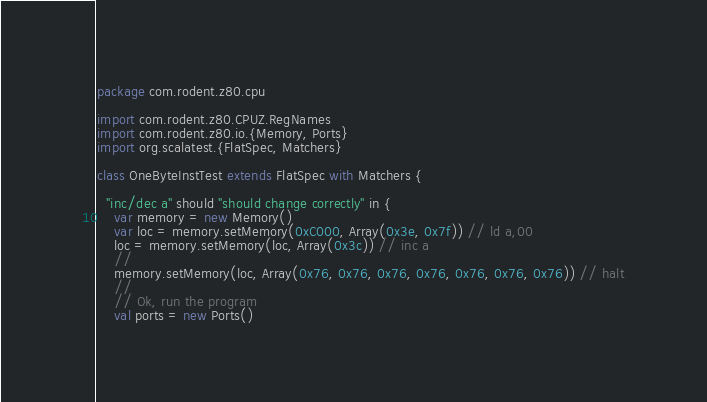Convert code to text. <code><loc_0><loc_0><loc_500><loc_500><_Scala_>package com.rodent.z80.cpu

import com.rodent.z80.CPUZ.RegNames
import com.rodent.z80.io.{Memory, Ports}
import org.scalatest.{FlatSpec, Matchers}

class OneByteInstTest extends FlatSpec with Matchers {

  "inc/dec a" should "should change correctly" in {
    var memory = new Memory()
    var loc = memory.setMemory(0xC000, Array(0x3e, 0x7f)) // ld a,00
    loc = memory.setMemory(loc, Array(0x3c)) // inc a
    //
    memory.setMemory(loc, Array(0x76, 0x76, 0x76, 0x76, 0x76, 0x76, 0x76)) // halt
    //
    // Ok, run the program
    val ports = new Ports()</code> 